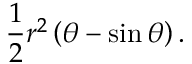Convert formula to latex. <formula><loc_0><loc_0><loc_500><loc_500>{ \frac { 1 } { 2 } } r ^ { 2 } \left ( \theta - \sin { \theta } \right ) .</formula> 